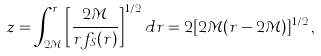<formula> <loc_0><loc_0><loc_500><loc_500>z = \int _ { 2 { \mathcal { M } } } ^ { r } \left [ \frac { 2 { \mathcal { M } } } { r f _ { S } ( r ) } \right ] ^ { 1 / 2 } d r = 2 [ 2 { \mathcal { M } } ( r - 2 { \mathcal { M } } ) ] ^ { 1 / 2 } \, ,</formula> 